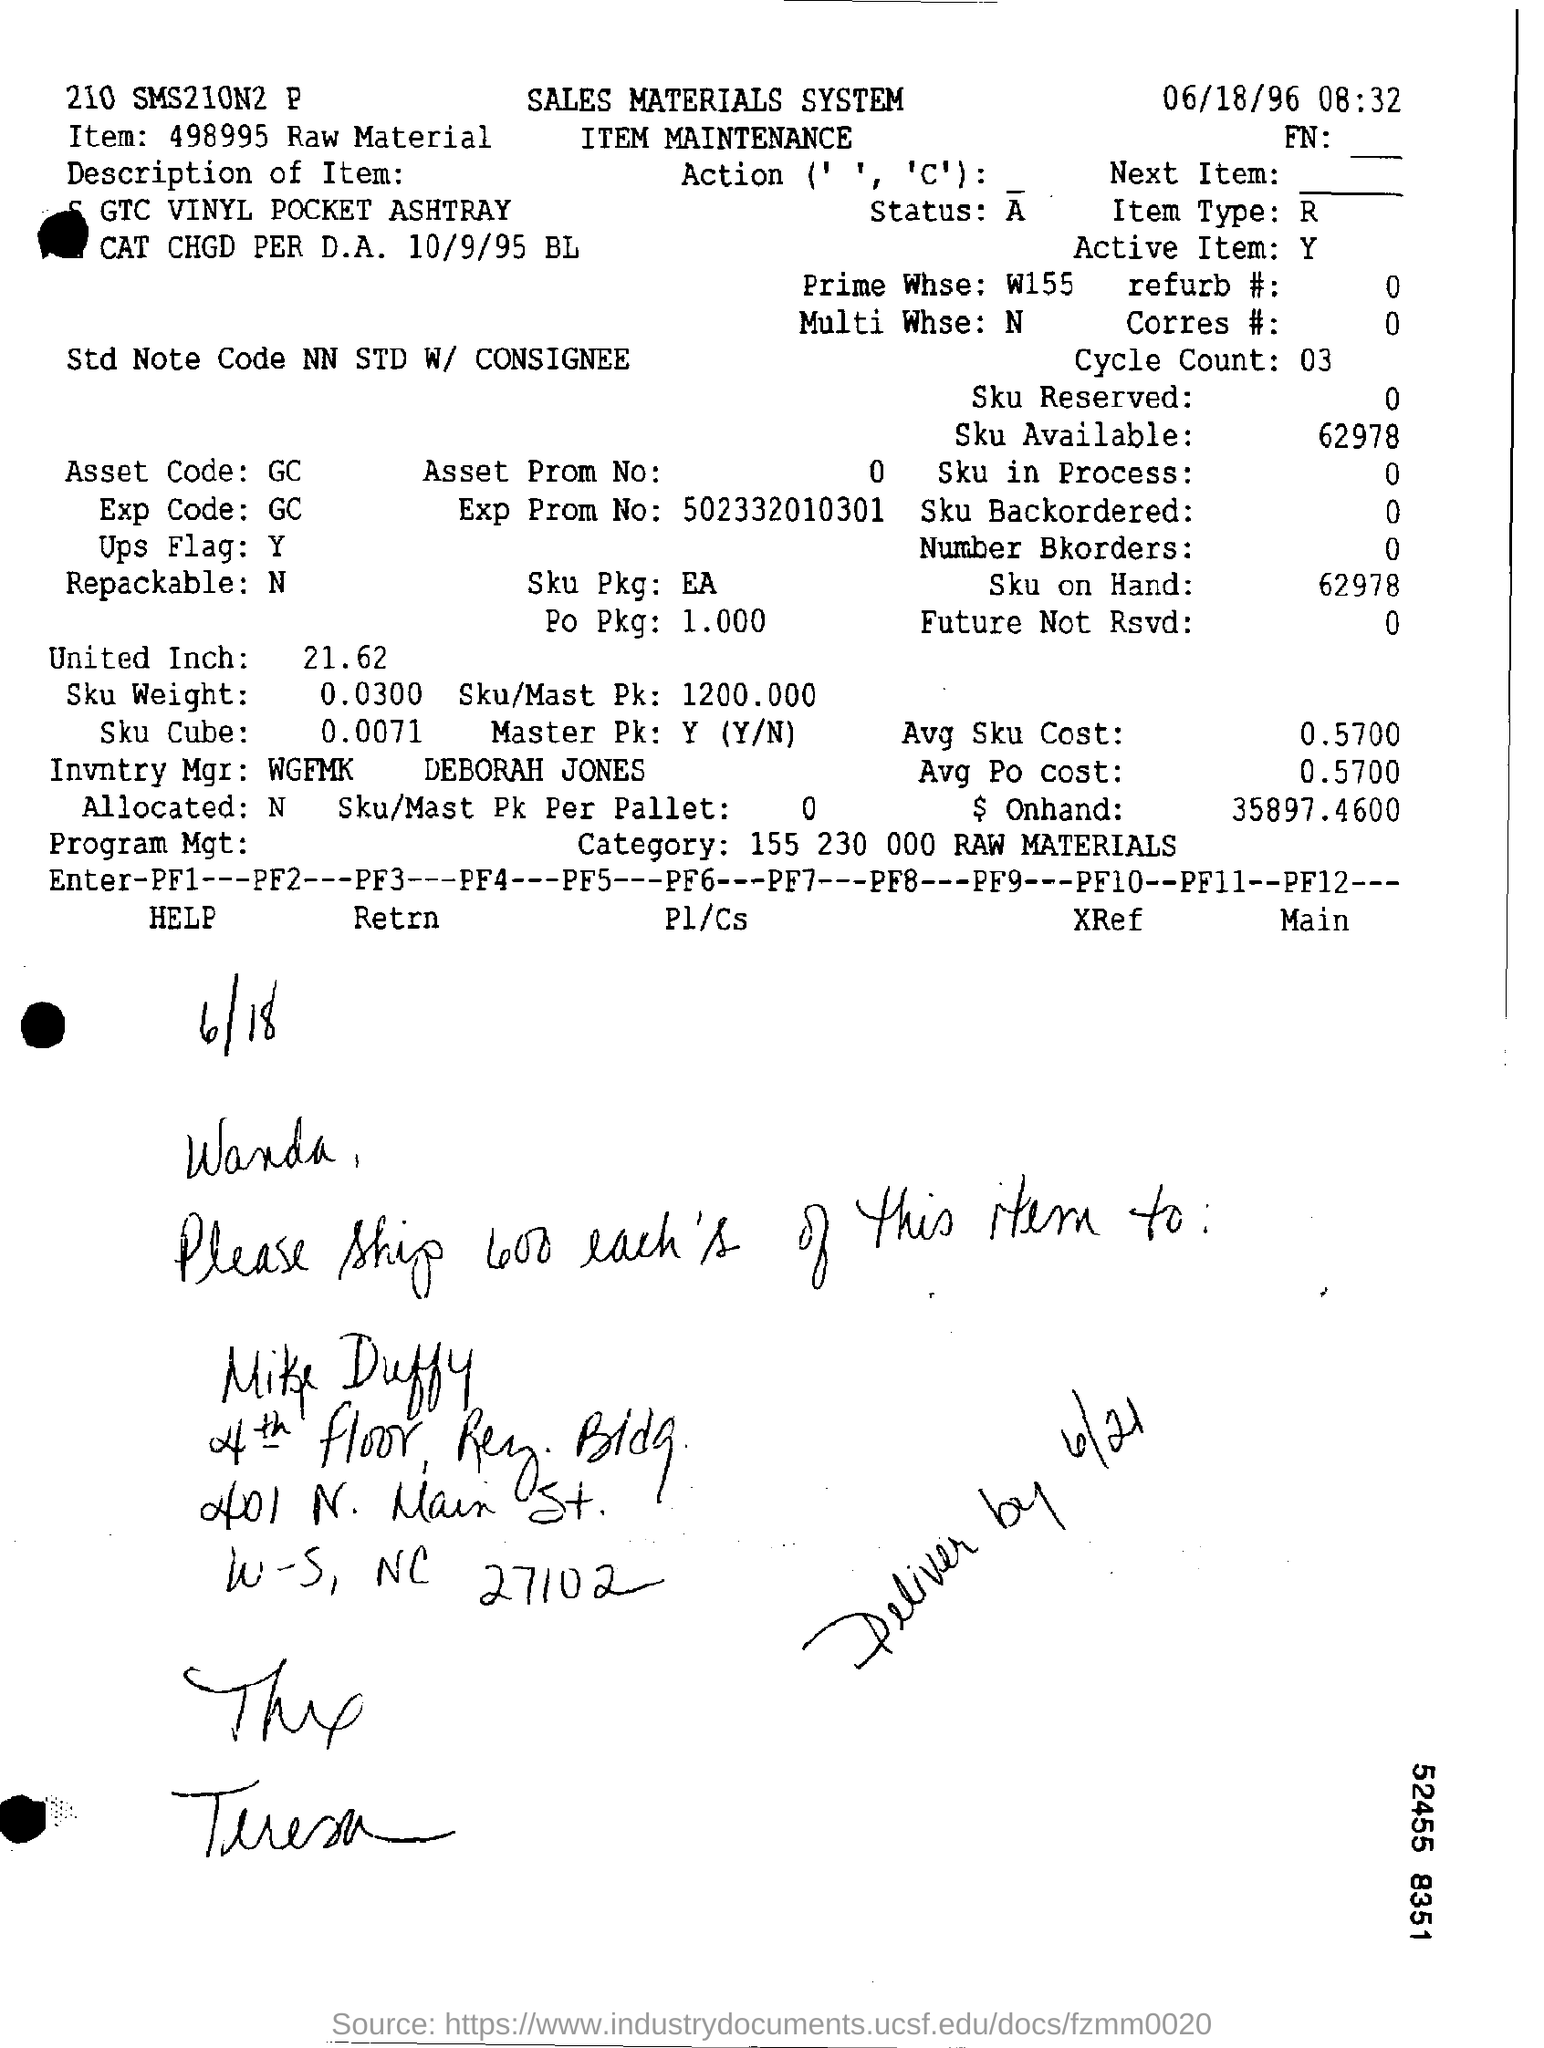Mention a couple of crucial points in this snapshot. The Repackable Field contains the value N... The item field contains the information '498995 raw material.' The letterhead contains information regarding the sales materials system. What is mentioned in the Active Item Field?" refers to the information or content that is currently highlighted or selected in the Active Item Field. The EXP Code Field mentions "GC. 